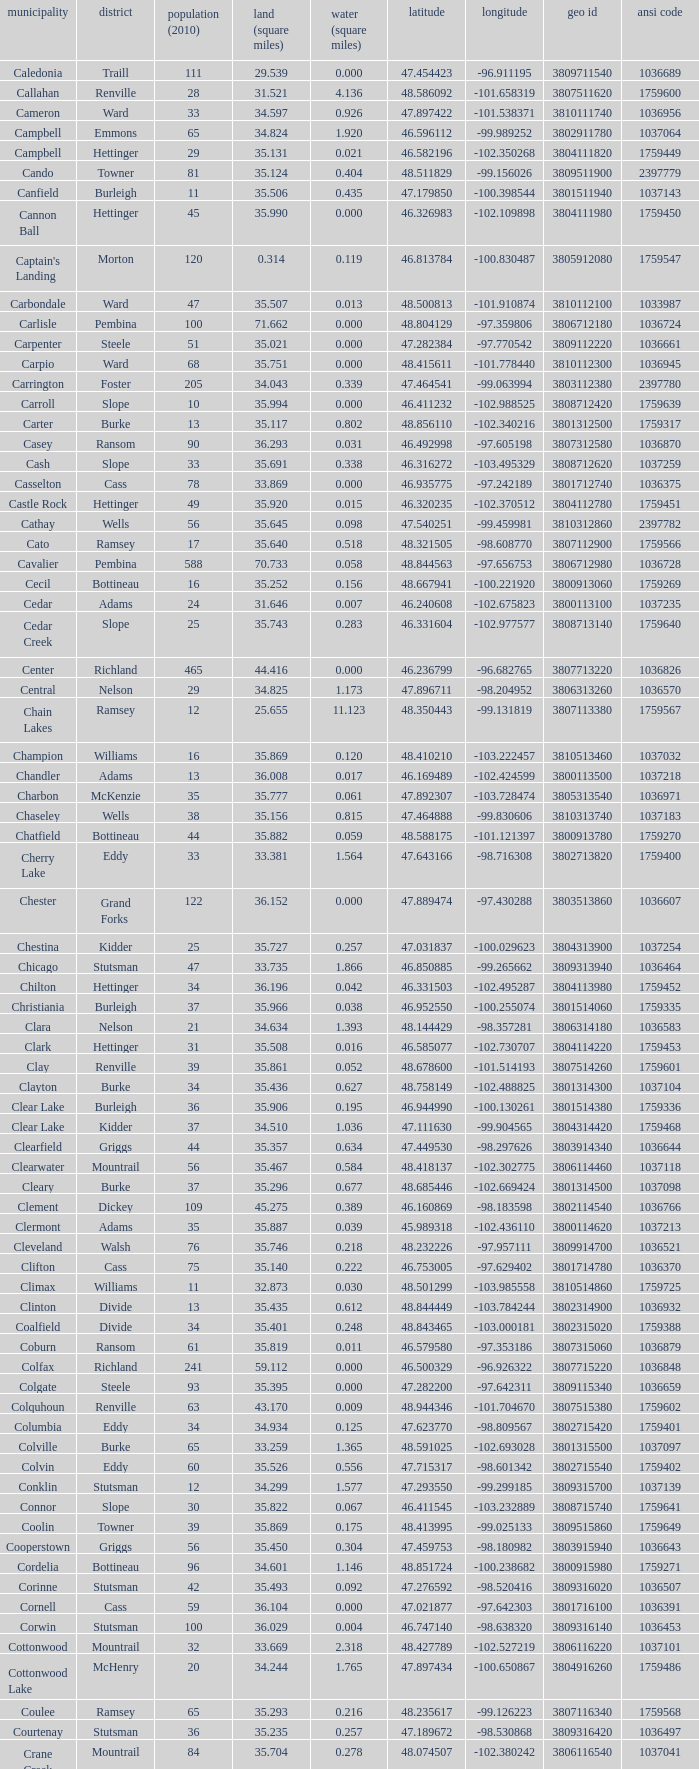What was the latitude of the Clearwater townsship? 48.418137. 